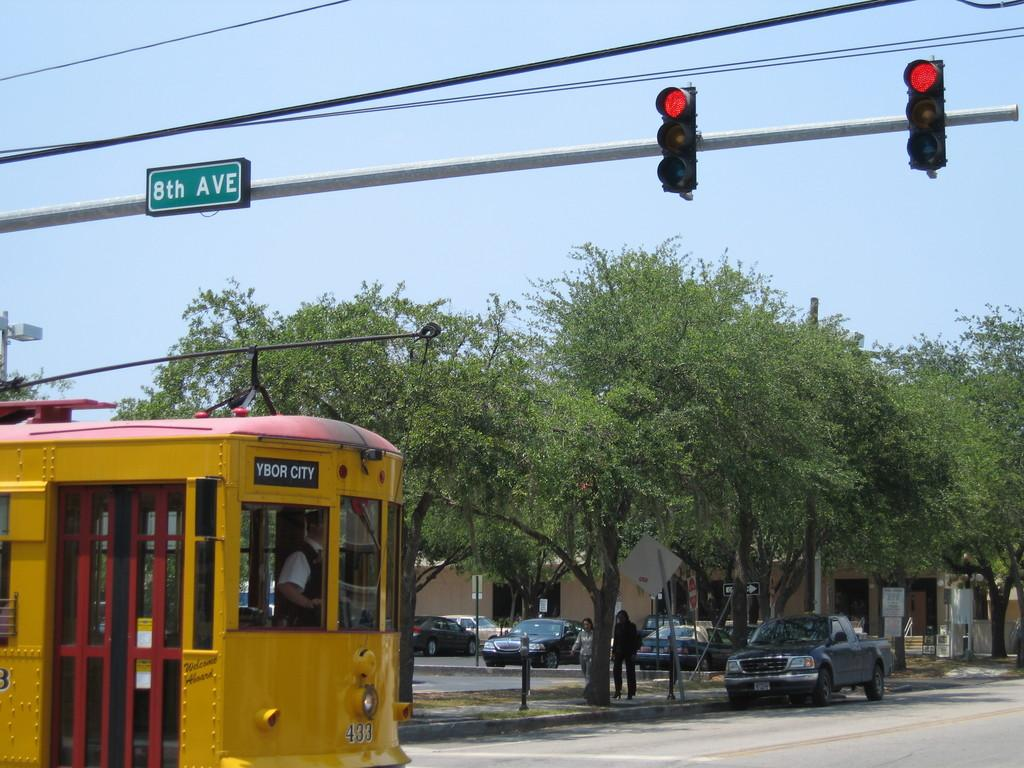Provide a one-sentence caption for the provided image. Trolley Bus Ybor City, passing an interaction where there is a Red Light showing. 